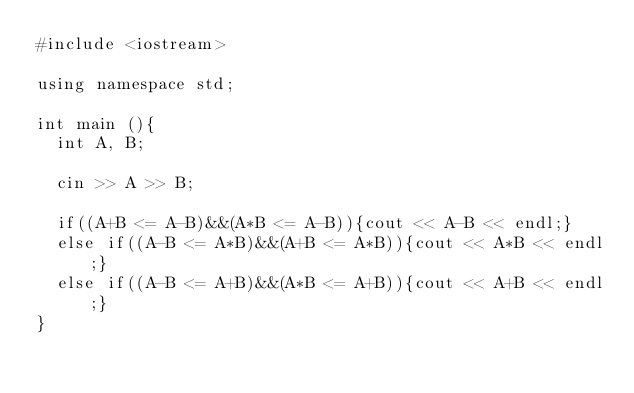Convert code to text. <code><loc_0><loc_0><loc_500><loc_500><_C++_>#include <iostream>

using namespace std;

int main (){
  int A, B;
  
  cin >> A >> B;
  
  if((A+B <= A-B)&&(A*B <= A-B)){cout << A-B << endl;}
  else if((A-B <= A*B)&&(A+B <= A*B)){cout << A*B << endl;}
  else if((A-B <= A+B)&&(A*B <= A+B)){cout << A+B << endl;}
}</code> 